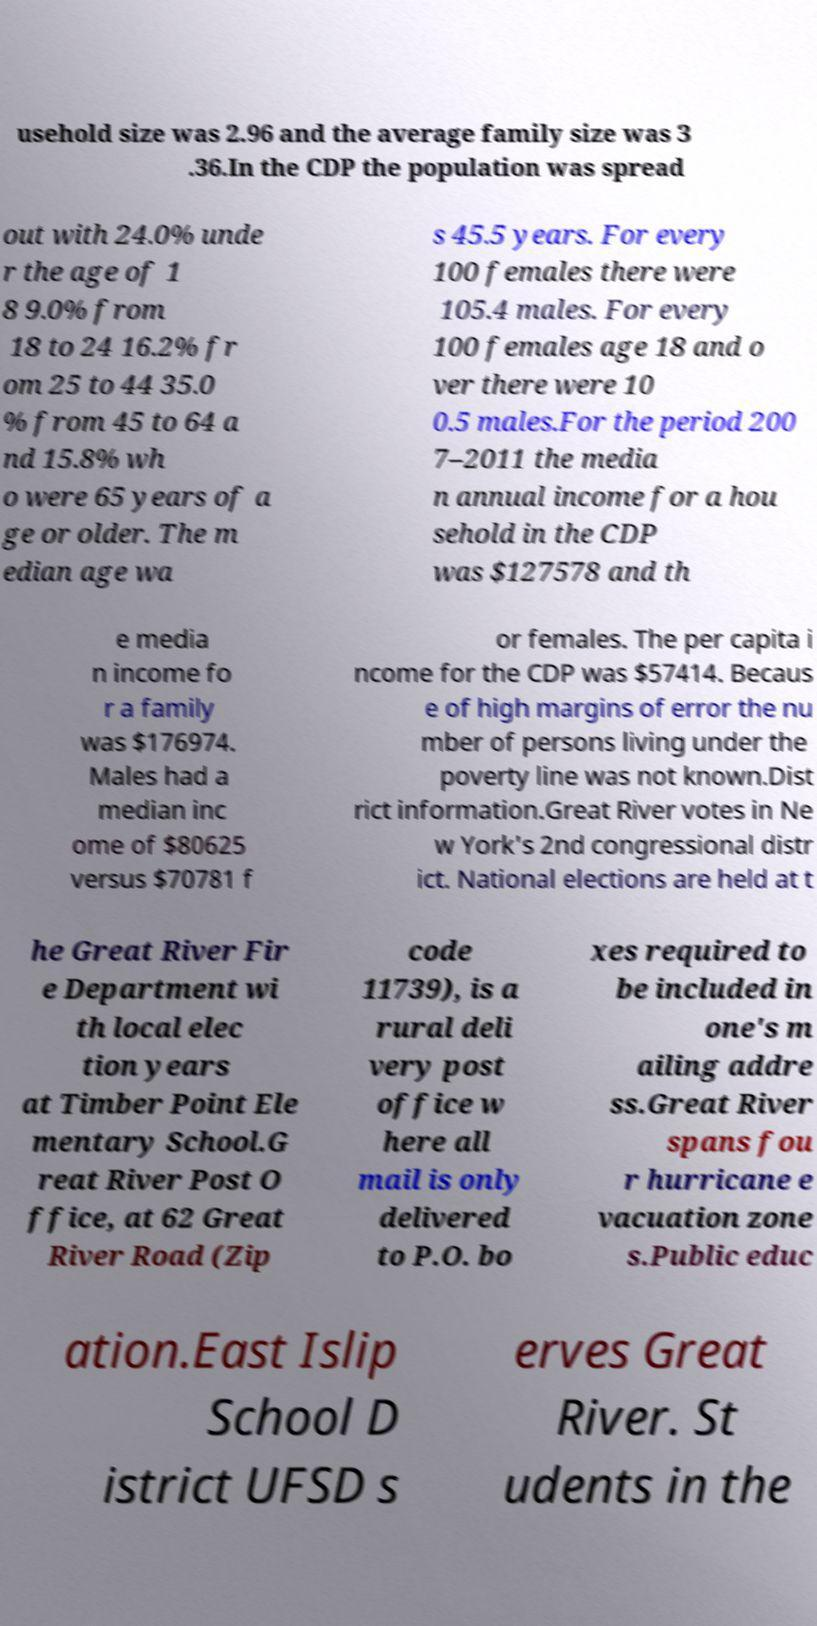For documentation purposes, I need the text within this image transcribed. Could you provide that? usehold size was 2.96 and the average family size was 3 .36.In the CDP the population was spread out with 24.0% unde r the age of 1 8 9.0% from 18 to 24 16.2% fr om 25 to 44 35.0 % from 45 to 64 a nd 15.8% wh o were 65 years of a ge or older. The m edian age wa s 45.5 years. For every 100 females there were 105.4 males. For every 100 females age 18 and o ver there were 10 0.5 males.For the period 200 7–2011 the media n annual income for a hou sehold in the CDP was $127578 and th e media n income fo r a family was $176974. Males had a median inc ome of $80625 versus $70781 f or females. The per capita i ncome for the CDP was $57414. Becaus e of high margins of error the nu mber of persons living under the poverty line was not known.Dist rict information.Great River votes in Ne w York's 2nd congressional distr ict. National elections are held at t he Great River Fir e Department wi th local elec tion years at Timber Point Ele mentary School.G reat River Post O ffice, at 62 Great River Road (Zip code 11739), is a rural deli very post office w here all mail is only delivered to P.O. bo xes required to be included in one's m ailing addre ss.Great River spans fou r hurricane e vacuation zone s.Public educ ation.East Islip School D istrict UFSD s erves Great River. St udents in the 